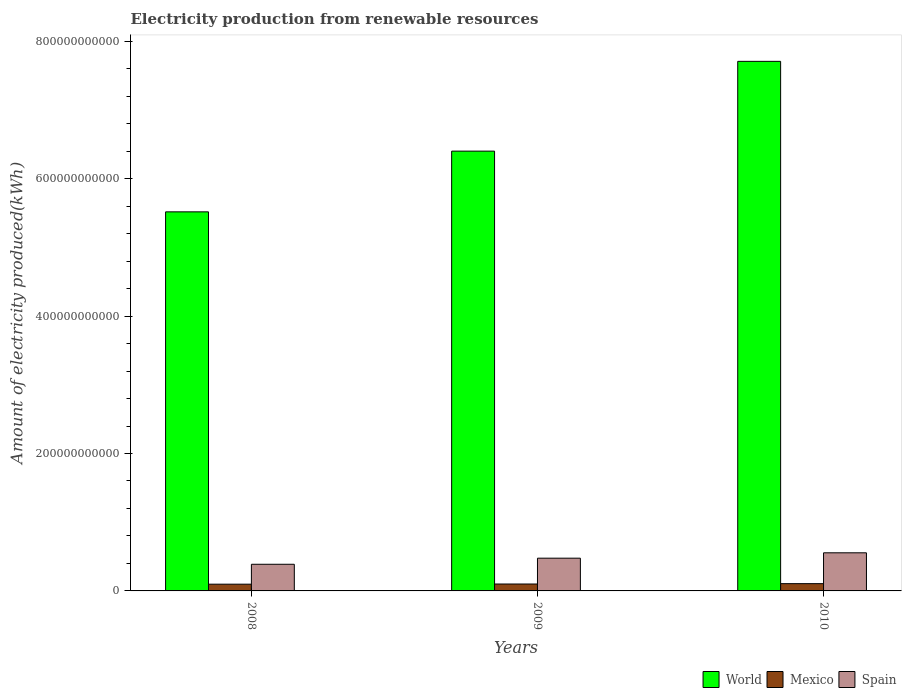How many different coloured bars are there?
Your answer should be compact. 3. How many bars are there on the 3rd tick from the left?
Offer a terse response. 3. In how many cases, is the number of bars for a given year not equal to the number of legend labels?
Keep it short and to the point. 0. What is the amount of electricity produced in Spain in 2008?
Provide a short and direct response. 3.88e+1. Across all years, what is the maximum amount of electricity produced in World?
Offer a very short reply. 7.71e+11. Across all years, what is the minimum amount of electricity produced in Spain?
Offer a terse response. 3.88e+1. In which year was the amount of electricity produced in World minimum?
Make the answer very short. 2008. What is the total amount of electricity produced in Mexico in the graph?
Keep it short and to the point. 3.04e+1. What is the difference between the amount of electricity produced in Mexico in 2008 and that in 2010?
Ensure brevity in your answer.  -7.73e+08. What is the difference between the amount of electricity produced in Spain in 2008 and the amount of electricity produced in Mexico in 2010?
Provide a short and direct response. 2.82e+1. What is the average amount of electricity produced in Spain per year?
Your response must be concise. 4.73e+1. In the year 2008, what is the difference between the amount of electricity produced in Spain and amount of electricity produced in World?
Make the answer very short. -5.13e+11. What is the ratio of the amount of electricity produced in Spain in 2008 to that in 2009?
Offer a very short reply. 0.81. Is the amount of electricity produced in Spain in 2009 less than that in 2010?
Offer a very short reply. Yes. What is the difference between the highest and the second highest amount of electricity produced in World?
Provide a succinct answer. 1.31e+11. What is the difference between the highest and the lowest amount of electricity produced in Spain?
Give a very brief answer. 1.67e+1. What does the 3rd bar from the right in 2008 represents?
Offer a very short reply. World. What is the difference between two consecutive major ticks on the Y-axis?
Ensure brevity in your answer.  2.00e+11. Are the values on the major ticks of Y-axis written in scientific E-notation?
Give a very brief answer. No. Does the graph contain grids?
Your answer should be compact. No. How many legend labels are there?
Your answer should be compact. 3. How are the legend labels stacked?
Give a very brief answer. Horizontal. What is the title of the graph?
Ensure brevity in your answer.  Electricity production from renewable resources. What is the label or title of the X-axis?
Offer a very short reply. Years. What is the label or title of the Y-axis?
Your answer should be compact. Amount of electricity produced(kWh). What is the Amount of electricity produced(kWh) of World in 2008?
Offer a terse response. 5.52e+11. What is the Amount of electricity produced(kWh) in Mexico in 2008?
Your answer should be very brief. 9.80e+09. What is the Amount of electricity produced(kWh) in Spain in 2008?
Your answer should be compact. 3.88e+1. What is the Amount of electricity produced(kWh) of World in 2009?
Ensure brevity in your answer.  6.40e+11. What is the Amount of electricity produced(kWh) of Mexico in 2009?
Keep it short and to the point. 1.01e+1. What is the Amount of electricity produced(kWh) in Spain in 2009?
Provide a succinct answer. 4.77e+1. What is the Amount of electricity produced(kWh) in World in 2010?
Make the answer very short. 7.71e+11. What is the Amount of electricity produced(kWh) in Mexico in 2010?
Ensure brevity in your answer.  1.06e+1. What is the Amount of electricity produced(kWh) of Spain in 2010?
Your answer should be very brief. 5.55e+1. Across all years, what is the maximum Amount of electricity produced(kWh) of World?
Give a very brief answer. 7.71e+11. Across all years, what is the maximum Amount of electricity produced(kWh) of Mexico?
Provide a short and direct response. 1.06e+1. Across all years, what is the maximum Amount of electricity produced(kWh) of Spain?
Keep it short and to the point. 5.55e+1. Across all years, what is the minimum Amount of electricity produced(kWh) of World?
Offer a terse response. 5.52e+11. Across all years, what is the minimum Amount of electricity produced(kWh) in Mexico?
Provide a short and direct response. 9.80e+09. Across all years, what is the minimum Amount of electricity produced(kWh) in Spain?
Provide a short and direct response. 3.88e+1. What is the total Amount of electricity produced(kWh) in World in the graph?
Offer a terse response. 1.96e+12. What is the total Amount of electricity produced(kWh) of Mexico in the graph?
Your answer should be very brief. 3.04e+1. What is the total Amount of electricity produced(kWh) of Spain in the graph?
Provide a short and direct response. 1.42e+11. What is the difference between the Amount of electricity produced(kWh) of World in 2008 and that in 2009?
Keep it short and to the point. -8.84e+1. What is the difference between the Amount of electricity produced(kWh) of Mexico in 2008 and that in 2009?
Provide a short and direct response. -2.62e+08. What is the difference between the Amount of electricity produced(kWh) in Spain in 2008 and that in 2009?
Your response must be concise. -8.89e+09. What is the difference between the Amount of electricity produced(kWh) in World in 2008 and that in 2010?
Ensure brevity in your answer.  -2.19e+11. What is the difference between the Amount of electricity produced(kWh) in Mexico in 2008 and that in 2010?
Offer a very short reply. -7.73e+08. What is the difference between the Amount of electricity produced(kWh) of Spain in 2008 and that in 2010?
Your answer should be compact. -1.67e+1. What is the difference between the Amount of electricity produced(kWh) of World in 2009 and that in 2010?
Provide a succinct answer. -1.31e+11. What is the difference between the Amount of electricity produced(kWh) of Mexico in 2009 and that in 2010?
Your response must be concise. -5.11e+08. What is the difference between the Amount of electricity produced(kWh) of Spain in 2009 and that in 2010?
Make the answer very short. -7.80e+09. What is the difference between the Amount of electricity produced(kWh) of World in 2008 and the Amount of electricity produced(kWh) of Mexico in 2009?
Your answer should be very brief. 5.42e+11. What is the difference between the Amount of electricity produced(kWh) in World in 2008 and the Amount of electricity produced(kWh) in Spain in 2009?
Your answer should be very brief. 5.04e+11. What is the difference between the Amount of electricity produced(kWh) in Mexico in 2008 and the Amount of electricity produced(kWh) in Spain in 2009?
Your answer should be very brief. -3.79e+1. What is the difference between the Amount of electricity produced(kWh) in World in 2008 and the Amount of electricity produced(kWh) in Mexico in 2010?
Your response must be concise. 5.41e+11. What is the difference between the Amount of electricity produced(kWh) in World in 2008 and the Amount of electricity produced(kWh) in Spain in 2010?
Ensure brevity in your answer.  4.96e+11. What is the difference between the Amount of electricity produced(kWh) of Mexico in 2008 and the Amount of electricity produced(kWh) of Spain in 2010?
Offer a terse response. -4.57e+1. What is the difference between the Amount of electricity produced(kWh) in World in 2009 and the Amount of electricity produced(kWh) in Mexico in 2010?
Give a very brief answer. 6.30e+11. What is the difference between the Amount of electricity produced(kWh) in World in 2009 and the Amount of electricity produced(kWh) in Spain in 2010?
Keep it short and to the point. 5.85e+11. What is the difference between the Amount of electricity produced(kWh) of Mexico in 2009 and the Amount of electricity produced(kWh) of Spain in 2010?
Keep it short and to the point. -4.54e+1. What is the average Amount of electricity produced(kWh) of World per year?
Your answer should be very brief. 6.54e+11. What is the average Amount of electricity produced(kWh) in Mexico per year?
Provide a succinct answer. 1.01e+1. What is the average Amount of electricity produced(kWh) in Spain per year?
Keep it short and to the point. 4.73e+1. In the year 2008, what is the difference between the Amount of electricity produced(kWh) in World and Amount of electricity produced(kWh) in Mexico?
Your answer should be very brief. 5.42e+11. In the year 2008, what is the difference between the Amount of electricity produced(kWh) in World and Amount of electricity produced(kWh) in Spain?
Offer a terse response. 5.13e+11. In the year 2008, what is the difference between the Amount of electricity produced(kWh) in Mexico and Amount of electricity produced(kWh) in Spain?
Offer a terse response. -2.90e+1. In the year 2009, what is the difference between the Amount of electricity produced(kWh) of World and Amount of electricity produced(kWh) of Mexico?
Your answer should be very brief. 6.30e+11. In the year 2009, what is the difference between the Amount of electricity produced(kWh) of World and Amount of electricity produced(kWh) of Spain?
Make the answer very short. 5.92e+11. In the year 2009, what is the difference between the Amount of electricity produced(kWh) of Mexico and Amount of electricity produced(kWh) of Spain?
Make the answer very short. -3.76e+1. In the year 2010, what is the difference between the Amount of electricity produced(kWh) of World and Amount of electricity produced(kWh) of Mexico?
Your answer should be compact. 7.60e+11. In the year 2010, what is the difference between the Amount of electricity produced(kWh) of World and Amount of electricity produced(kWh) of Spain?
Make the answer very short. 7.15e+11. In the year 2010, what is the difference between the Amount of electricity produced(kWh) of Mexico and Amount of electricity produced(kWh) of Spain?
Ensure brevity in your answer.  -4.49e+1. What is the ratio of the Amount of electricity produced(kWh) in World in 2008 to that in 2009?
Your response must be concise. 0.86. What is the ratio of the Amount of electricity produced(kWh) in Spain in 2008 to that in 2009?
Your response must be concise. 0.81. What is the ratio of the Amount of electricity produced(kWh) of World in 2008 to that in 2010?
Provide a short and direct response. 0.72. What is the ratio of the Amount of electricity produced(kWh) of Mexico in 2008 to that in 2010?
Provide a succinct answer. 0.93. What is the ratio of the Amount of electricity produced(kWh) in Spain in 2008 to that in 2010?
Your response must be concise. 0.7. What is the ratio of the Amount of electricity produced(kWh) in World in 2009 to that in 2010?
Your response must be concise. 0.83. What is the ratio of the Amount of electricity produced(kWh) of Mexico in 2009 to that in 2010?
Keep it short and to the point. 0.95. What is the ratio of the Amount of electricity produced(kWh) in Spain in 2009 to that in 2010?
Your response must be concise. 0.86. What is the difference between the highest and the second highest Amount of electricity produced(kWh) of World?
Make the answer very short. 1.31e+11. What is the difference between the highest and the second highest Amount of electricity produced(kWh) in Mexico?
Keep it short and to the point. 5.11e+08. What is the difference between the highest and the second highest Amount of electricity produced(kWh) of Spain?
Give a very brief answer. 7.80e+09. What is the difference between the highest and the lowest Amount of electricity produced(kWh) of World?
Keep it short and to the point. 2.19e+11. What is the difference between the highest and the lowest Amount of electricity produced(kWh) of Mexico?
Offer a terse response. 7.73e+08. What is the difference between the highest and the lowest Amount of electricity produced(kWh) in Spain?
Offer a terse response. 1.67e+1. 